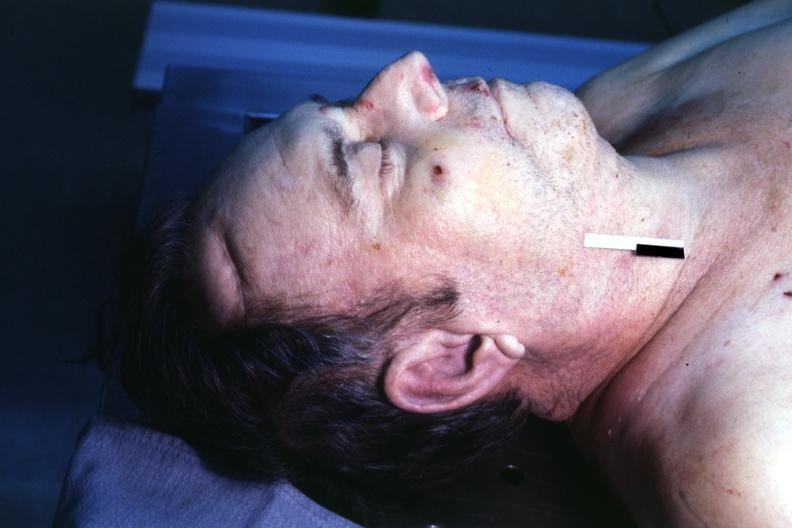what does this image show?
Answer the question using a single word or phrase. Body on autopsy table lesion that supposedly predicts premature coronary disease is easily seen 